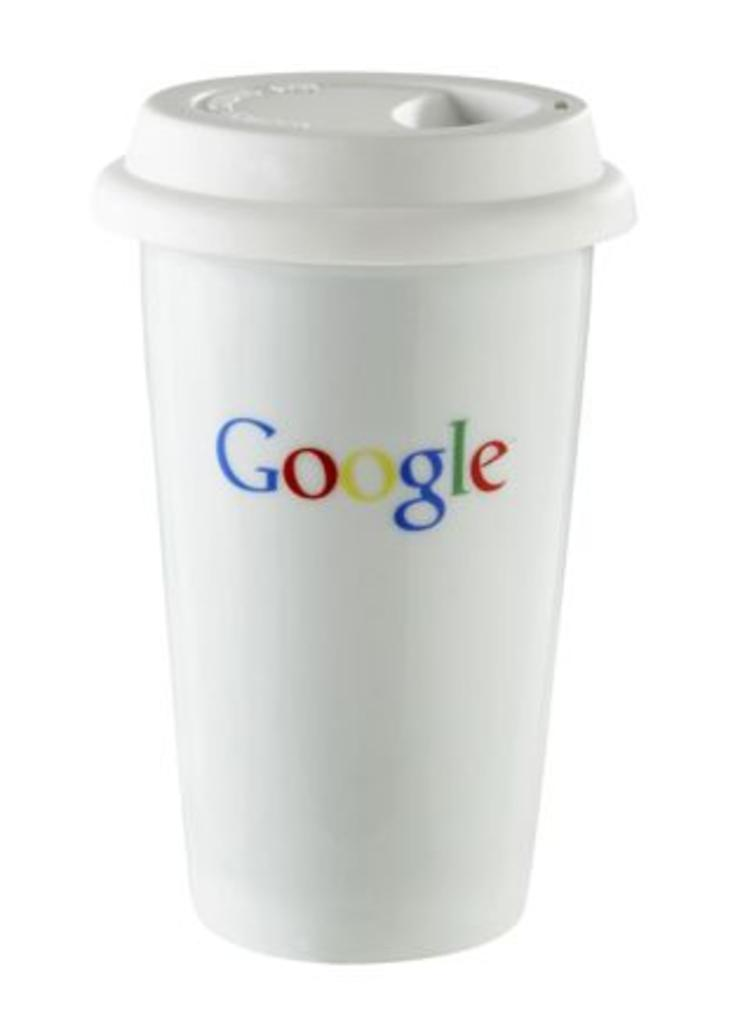<image>
Provide a brief description of the given image. A cup has a lid and a Google logo on it. 